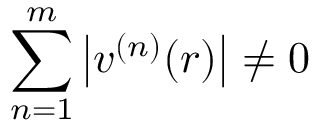<formula> <loc_0><loc_0><loc_500><loc_500>\sum _ { n = 1 } ^ { m } \left | v ^ { ( n ) } ( r ) \right | \ne 0</formula> 